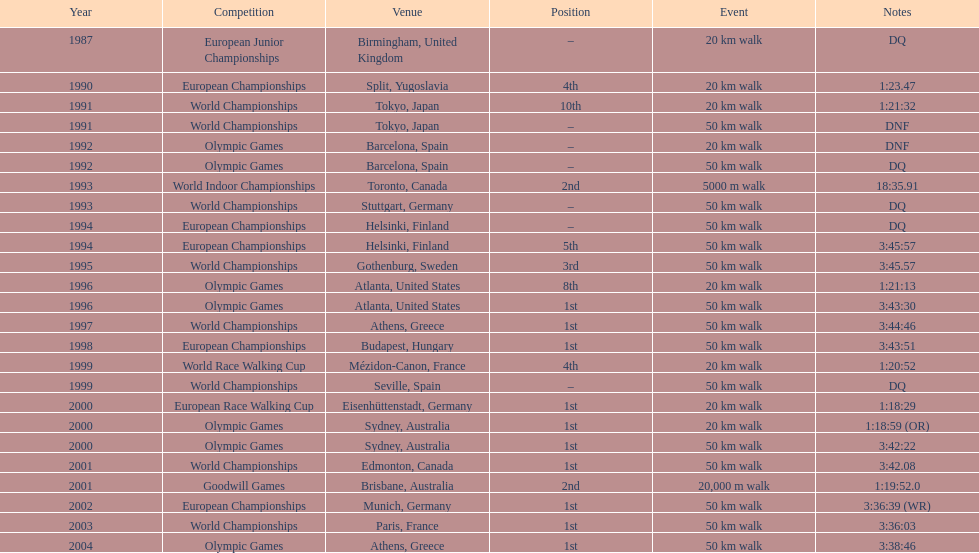Can you parse all the data within this table? {'header': ['Year', 'Competition', 'Venue', 'Position', 'Event', 'Notes'], 'rows': [['1987', 'European Junior Championships', 'Birmingham, United Kingdom', '–', '20\xa0km walk', 'DQ'], ['1990', 'European Championships', 'Split, Yugoslavia', '4th', '20\xa0km walk', '1:23.47'], ['1991', 'World Championships', 'Tokyo, Japan', '10th', '20\xa0km walk', '1:21:32'], ['1991', 'World Championships', 'Tokyo, Japan', '–', '50\xa0km walk', 'DNF'], ['1992', 'Olympic Games', 'Barcelona, Spain', '–', '20\xa0km walk', 'DNF'], ['1992', 'Olympic Games', 'Barcelona, Spain', '–', '50\xa0km walk', 'DQ'], ['1993', 'World Indoor Championships', 'Toronto, Canada', '2nd', '5000 m walk', '18:35.91'], ['1993', 'World Championships', 'Stuttgart, Germany', '–', '50\xa0km walk', 'DQ'], ['1994', 'European Championships', 'Helsinki, Finland', '–', '50\xa0km walk', 'DQ'], ['1994', 'European Championships', 'Helsinki, Finland', '5th', '50\xa0km walk', '3:45:57'], ['1995', 'World Championships', 'Gothenburg, Sweden', '3rd', '50\xa0km walk', '3:45.57'], ['1996', 'Olympic Games', 'Atlanta, United States', '8th', '20\xa0km walk', '1:21:13'], ['1996', 'Olympic Games', 'Atlanta, United States', '1st', '50\xa0km walk', '3:43:30'], ['1997', 'World Championships', 'Athens, Greece', '1st', '50\xa0km walk', '3:44:46'], ['1998', 'European Championships', 'Budapest, Hungary', '1st', '50\xa0km walk', '3:43:51'], ['1999', 'World Race Walking Cup', 'Mézidon-Canon, France', '4th', '20\xa0km walk', '1:20:52'], ['1999', 'World Championships', 'Seville, Spain', '–', '50\xa0km walk', 'DQ'], ['2000', 'European Race Walking Cup', 'Eisenhüttenstadt, Germany', '1st', '20\xa0km walk', '1:18:29'], ['2000', 'Olympic Games', 'Sydney, Australia', '1st', '20\xa0km walk', '1:18:59 (OR)'], ['2000', 'Olympic Games', 'Sydney, Australia', '1st', '50\xa0km walk', '3:42:22'], ['2001', 'World Championships', 'Edmonton, Canada', '1st', '50\xa0km walk', '3:42.08'], ['2001', 'Goodwill Games', 'Brisbane, Australia', '2nd', '20,000 m walk', '1:19:52.0'], ['2002', 'European Championships', 'Munich, Germany', '1st', '50\xa0km walk', '3:36:39 (WR)'], ['2003', 'World Championships', 'Paris, France', '1st', '50\xa0km walk', '3:36:03'], ['2004', 'Olympic Games', 'Athens, Greece', '1st', '50\xa0km walk', '3:38:46']]} How many times did korzeniowski rank above fourth place in competitions? 13. 